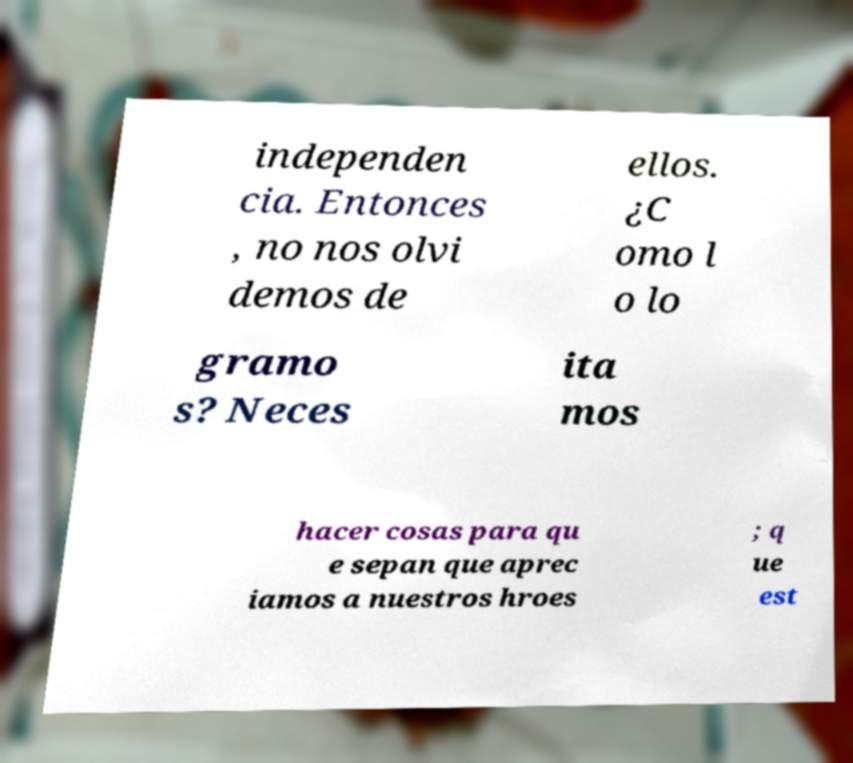Please read and relay the text visible in this image. What does it say? independen cia. Entonces , no nos olvi demos de ellos. ¿C omo l o lo gramo s? Neces ita mos hacer cosas para qu e sepan que aprec iamos a nuestros hroes ; q ue est 